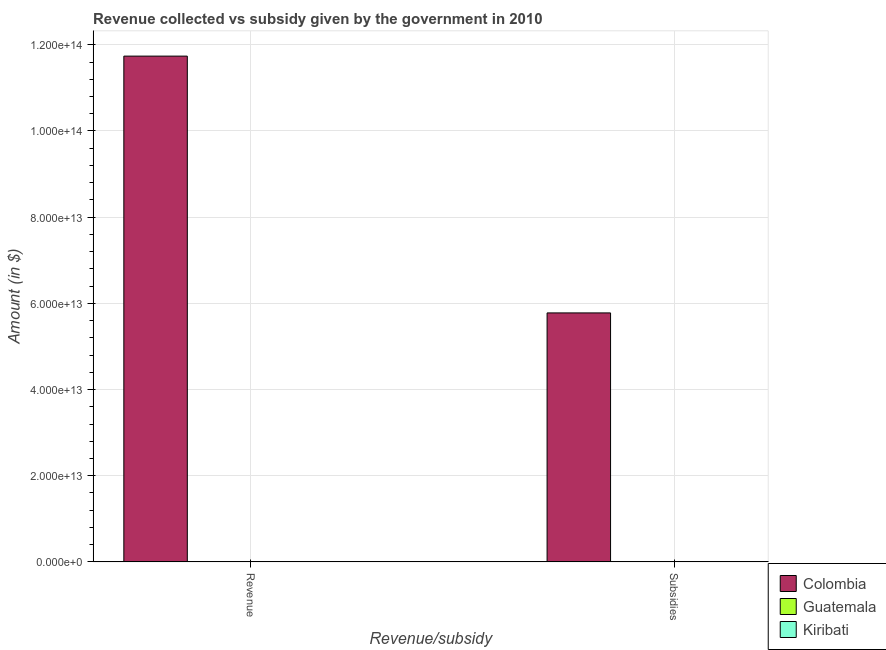How many groups of bars are there?
Provide a short and direct response. 2. What is the label of the 1st group of bars from the left?
Provide a succinct answer. Revenue. What is the amount of subsidies given in Kiribati?
Keep it short and to the point. 9.01e+06. Across all countries, what is the maximum amount of revenue collected?
Offer a terse response. 1.17e+14. Across all countries, what is the minimum amount of subsidies given?
Make the answer very short. 9.01e+06. In which country was the amount of revenue collected maximum?
Offer a very short reply. Colombia. In which country was the amount of revenue collected minimum?
Keep it short and to the point. Kiribati. What is the total amount of revenue collected in the graph?
Offer a terse response. 1.17e+14. What is the difference between the amount of subsidies given in Kiribati and that in Guatemala?
Give a very brief answer. -1.33e+1. What is the difference between the amount of subsidies given in Guatemala and the amount of revenue collected in Colombia?
Provide a succinct answer. -1.17e+14. What is the average amount of subsidies given per country?
Ensure brevity in your answer.  1.93e+13. What is the difference between the amount of subsidies given and amount of revenue collected in Guatemala?
Offer a terse response. -2.35e+1. What is the ratio of the amount of subsidies given in Colombia to that in Kiribati?
Your answer should be compact. 6.41e+06. In how many countries, is the amount of revenue collected greater than the average amount of revenue collected taken over all countries?
Your answer should be very brief. 1. What does the 2nd bar from the left in Revenue represents?
Your answer should be very brief. Guatemala. What does the 1st bar from the right in Revenue represents?
Your answer should be compact. Kiribati. Are all the bars in the graph horizontal?
Provide a short and direct response. No. How many countries are there in the graph?
Your answer should be very brief. 3. What is the difference between two consecutive major ticks on the Y-axis?
Your answer should be very brief. 2.00e+13. Does the graph contain grids?
Make the answer very short. Yes. Where does the legend appear in the graph?
Keep it short and to the point. Bottom right. How are the legend labels stacked?
Keep it short and to the point. Vertical. What is the title of the graph?
Provide a succinct answer. Revenue collected vs subsidy given by the government in 2010. What is the label or title of the X-axis?
Your answer should be compact. Revenue/subsidy. What is the label or title of the Y-axis?
Provide a short and direct response. Amount (in $). What is the Amount (in $) in Colombia in Revenue?
Provide a short and direct response. 1.17e+14. What is the Amount (in $) in Guatemala in Revenue?
Give a very brief answer. 3.69e+1. What is the Amount (in $) of Kiribati in Revenue?
Ensure brevity in your answer.  9.63e+07. What is the Amount (in $) of Colombia in Subsidies?
Give a very brief answer. 5.78e+13. What is the Amount (in $) in Guatemala in Subsidies?
Ensure brevity in your answer.  1.33e+1. What is the Amount (in $) of Kiribati in Subsidies?
Give a very brief answer. 9.01e+06. Across all Revenue/subsidy, what is the maximum Amount (in $) in Colombia?
Your answer should be very brief. 1.17e+14. Across all Revenue/subsidy, what is the maximum Amount (in $) in Guatemala?
Provide a succinct answer. 3.69e+1. Across all Revenue/subsidy, what is the maximum Amount (in $) in Kiribati?
Provide a succinct answer. 9.63e+07. Across all Revenue/subsidy, what is the minimum Amount (in $) in Colombia?
Make the answer very short. 5.78e+13. Across all Revenue/subsidy, what is the minimum Amount (in $) in Guatemala?
Your response must be concise. 1.33e+1. Across all Revenue/subsidy, what is the minimum Amount (in $) in Kiribati?
Your answer should be compact. 9.01e+06. What is the total Amount (in $) of Colombia in the graph?
Make the answer very short. 1.75e+14. What is the total Amount (in $) in Guatemala in the graph?
Provide a short and direct response. 5.02e+1. What is the total Amount (in $) in Kiribati in the graph?
Ensure brevity in your answer.  1.05e+08. What is the difference between the Amount (in $) in Colombia in Revenue and that in Subsidies?
Make the answer very short. 5.96e+13. What is the difference between the Amount (in $) of Guatemala in Revenue and that in Subsidies?
Your answer should be compact. 2.35e+1. What is the difference between the Amount (in $) of Kiribati in Revenue and that in Subsidies?
Keep it short and to the point. 8.73e+07. What is the difference between the Amount (in $) of Colombia in Revenue and the Amount (in $) of Guatemala in Subsidies?
Your response must be concise. 1.17e+14. What is the difference between the Amount (in $) in Colombia in Revenue and the Amount (in $) in Kiribati in Subsidies?
Provide a succinct answer. 1.17e+14. What is the difference between the Amount (in $) of Guatemala in Revenue and the Amount (in $) of Kiribati in Subsidies?
Your answer should be compact. 3.69e+1. What is the average Amount (in $) in Colombia per Revenue/subsidy?
Offer a terse response. 8.76e+13. What is the average Amount (in $) in Guatemala per Revenue/subsidy?
Offer a terse response. 2.51e+1. What is the average Amount (in $) in Kiribati per Revenue/subsidy?
Offer a terse response. 5.26e+07. What is the difference between the Amount (in $) of Colombia and Amount (in $) of Guatemala in Revenue?
Ensure brevity in your answer.  1.17e+14. What is the difference between the Amount (in $) in Colombia and Amount (in $) in Kiribati in Revenue?
Give a very brief answer. 1.17e+14. What is the difference between the Amount (in $) in Guatemala and Amount (in $) in Kiribati in Revenue?
Ensure brevity in your answer.  3.68e+1. What is the difference between the Amount (in $) of Colombia and Amount (in $) of Guatemala in Subsidies?
Offer a terse response. 5.78e+13. What is the difference between the Amount (in $) of Colombia and Amount (in $) of Kiribati in Subsidies?
Ensure brevity in your answer.  5.78e+13. What is the difference between the Amount (in $) of Guatemala and Amount (in $) of Kiribati in Subsidies?
Provide a short and direct response. 1.33e+1. What is the ratio of the Amount (in $) in Colombia in Revenue to that in Subsidies?
Provide a succinct answer. 2.03. What is the ratio of the Amount (in $) in Guatemala in Revenue to that in Subsidies?
Your answer should be compact. 2.76. What is the ratio of the Amount (in $) of Kiribati in Revenue to that in Subsidies?
Keep it short and to the point. 10.69. What is the difference between the highest and the second highest Amount (in $) of Colombia?
Keep it short and to the point. 5.96e+13. What is the difference between the highest and the second highest Amount (in $) in Guatemala?
Give a very brief answer. 2.35e+1. What is the difference between the highest and the second highest Amount (in $) of Kiribati?
Provide a short and direct response. 8.73e+07. What is the difference between the highest and the lowest Amount (in $) in Colombia?
Your answer should be very brief. 5.96e+13. What is the difference between the highest and the lowest Amount (in $) in Guatemala?
Offer a very short reply. 2.35e+1. What is the difference between the highest and the lowest Amount (in $) of Kiribati?
Your answer should be compact. 8.73e+07. 